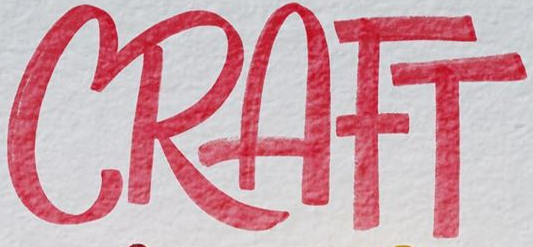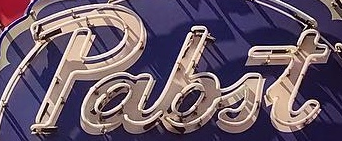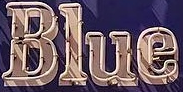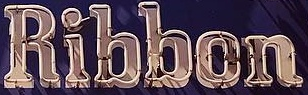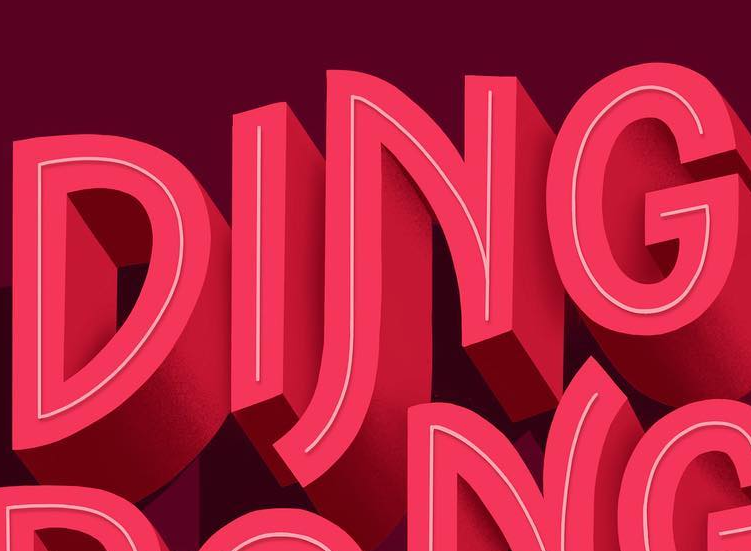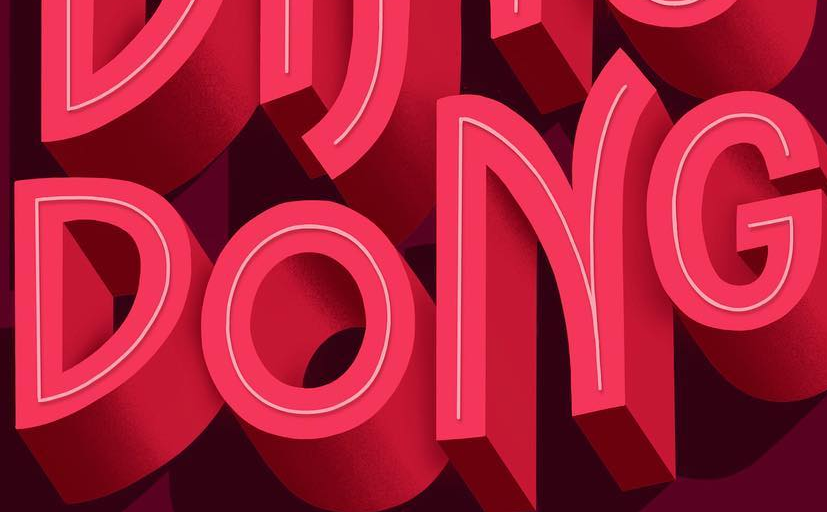Transcribe the words shown in these images in order, separated by a semicolon. CRAFT; pabit; Blue; Ribbon; DING; DONG 